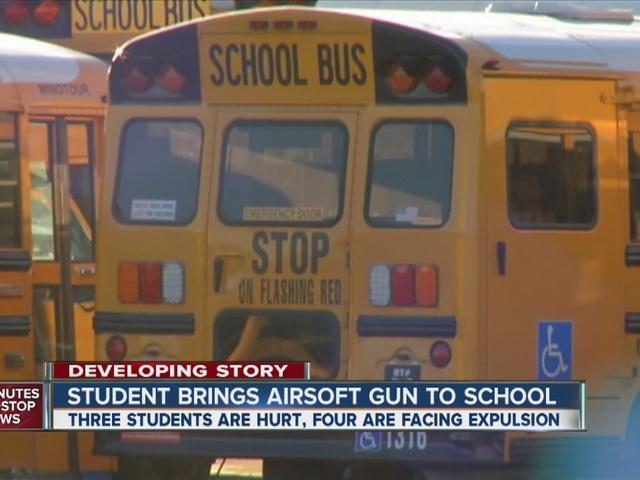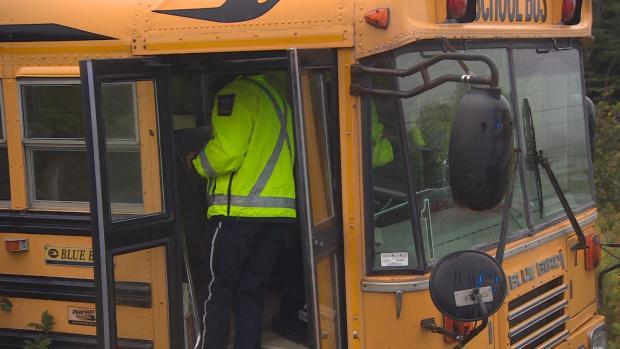The first image is the image on the left, the second image is the image on the right. Evaluate the accuracy of this statement regarding the images: "There are exactly two buses.". Is it true? Answer yes or no. No. The first image is the image on the left, the second image is the image on the right. For the images shown, is this caption "Two rectangular rear view mirrors are visible in the righthand image but neither are located on the right side of the image." true? Answer yes or no. No. 